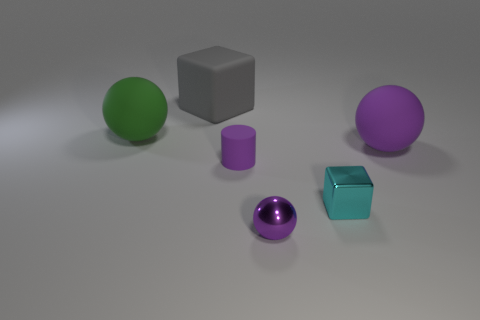Subtract all tiny metallic balls. How many balls are left? 2 Add 1 tiny purple objects. How many objects exist? 7 Subtract all green spheres. How many spheres are left? 2 Subtract 1 spheres. How many spheres are left? 2 Subtract all blocks. How many objects are left? 4 Add 1 tiny cyan objects. How many tiny cyan objects exist? 2 Subtract 1 green balls. How many objects are left? 5 Subtract all blue blocks. Subtract all blue spheres. How many blocks are left? 2 Subtract all brown spheres. How many gray cubes are left? 1 Subtract all rubber spheres. Subtract all cylinders. How many objects are left? 3 